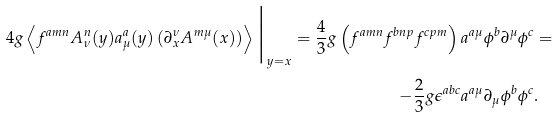<formula> <loc_0><loc_0><loc_500><loc_500>4 g \left \langle f ^ { a m n } A ^ { n } _ { \nu } ( y ) a ^ { a } _ { \mu } ( y ) \left ( \partial ^ { \nu } _ { x } A ^ { m \mu } ( x ) \right ) \right \rangle \Big | _ { y = x } = \frac { 4 } { 3 } g \left ( f ^ { a m n } f ^ { b n p } f ^ { c p m } \right ) a ^ { a \mu } \phi ^ { b } \partial ^ { \mu } \phi ^ { c } & = \\ - \frac { 2 } { 3 } g \epsilon ^ { a b c } a ^ { a \mu } \partial _ { \mu } \phi ^ { b } \phi ^ { c } & .</formula> 